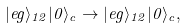<formula> <loc_0><loc_0><loc_500><loc_500>| e g \rangle _ { 1 2 } | 0 \rangle _ { c } \rightarrow | e g \rangle _ { 1 2 } | 0 \rangle _ { c } ,</formula> 